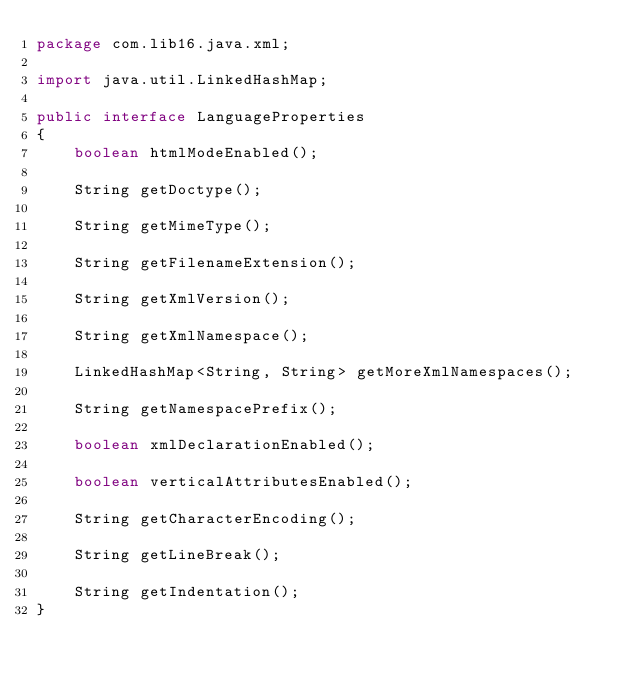<code> <loc_0><loc_0><loc_500><loc_500><_Java_>package com.lib16.java.xml;

import java.util.LinkedHashMap;

public interface LanguageProperties
{
	boolean htmlModeEnabled();

	String getDoctype();

	String getMimeType();

	String getFilenameExtension();

	String getXmlVersion();

	String getXmlNamespace();

	LinkedHashMap<String, String> getMoreXmlNamespaces();

	String getNamespacePrefix();

	boolean xmlDeclarationEnabled();

	boolean verticalAttributesEnabled();

	String getCharacterEncoding();

	String getLineBreak();

	String getIndentation();
}
</code> 